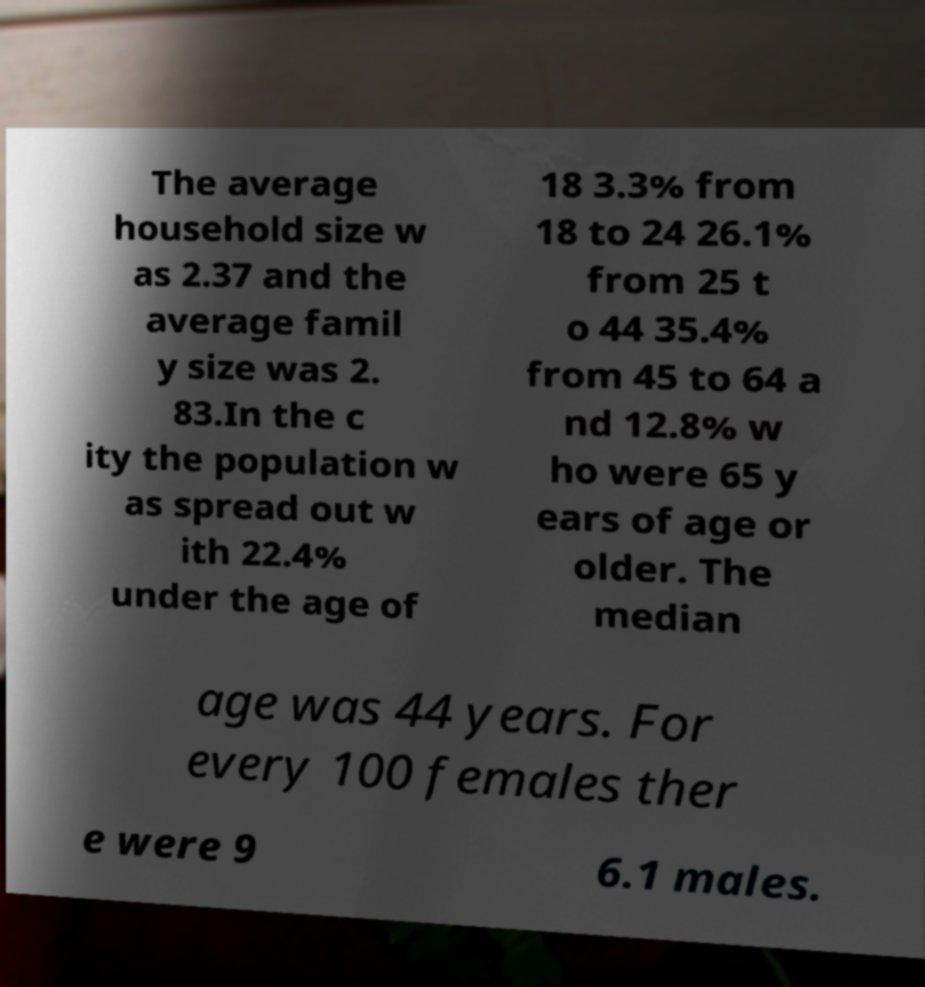Please read and relay the text visible in this image. What does it say? The average household size w as 2.37 and the average famil y size was 2. 83.In the c ity the population w as spread out w ith 22.4% under the age of 18 3.3% from 18 to 24 26.1% from 25 t o 44 35.4% from 45 to 64 a nd 12.8% w ho were 65 y ears of age or older. The median age was 44 years. For every 100 females ther e were 9 6.1 males. 